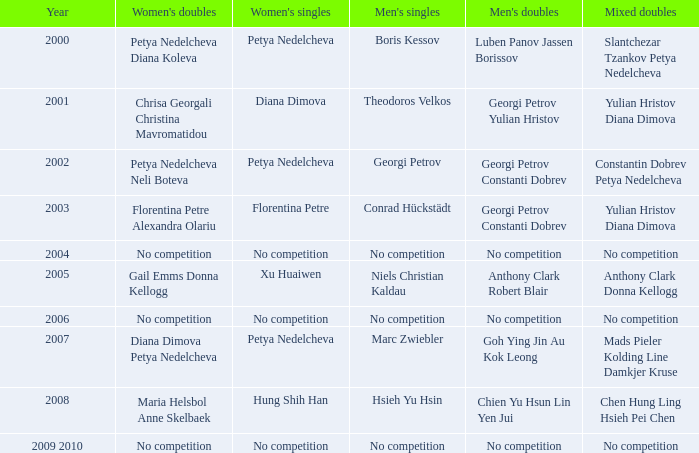Who won the Men's Double the same year as Florentina Petre winning the Women's Singles? Georgi Petrov Constanti Dobrev. 